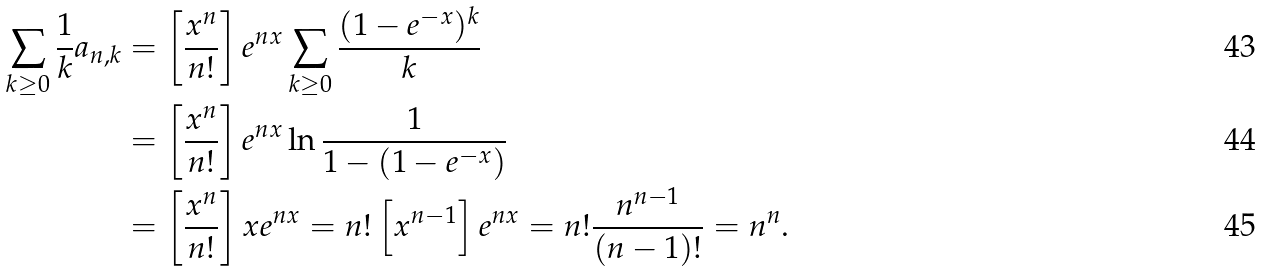<formula> <loc_0><loc_0><loc_500><loc_500>\sum _ { k \geq 0 } \frac { 1 } { k } a _ { n , k } & = \left [ \frac { x ^ { n } } { n ! } \right ] e ^ { n x } \sum _ { k \geq 0 } \frac { ( 1 - e ^ { - x } ) ^ { k } } { k } \\ & = \left [ \frac { x ^ { n } } { n ! } \right ] e ^ { n x } \ln \frac { 1 } { 1 - ( 1 - e ^ { - x } ) } \\ & = \left [ \frac { x ^ { n } } { n ! } \right ] x e ^ { n x } = n ! \left [ x ^ { n - 1 } \right ] e ^ { n x } = n ! \frac { n ^ { n - 1 } } { ( n - 1 ) ! } = n ^ { n } .</formula> 